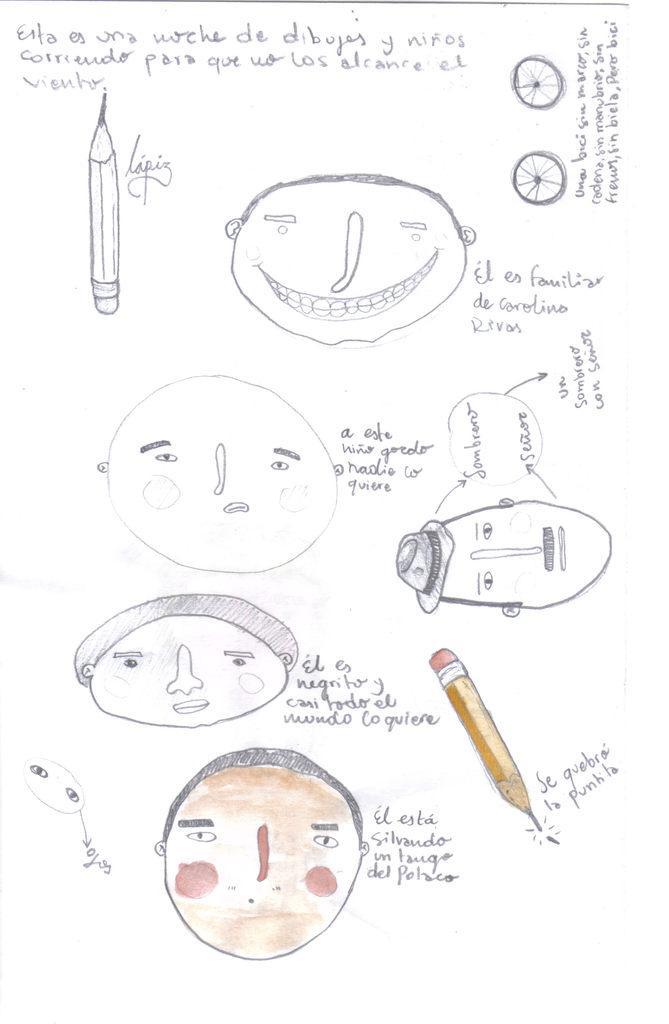Could you give a brief overview of what you see in this image? In this picture we can see few drawings on the paper. 